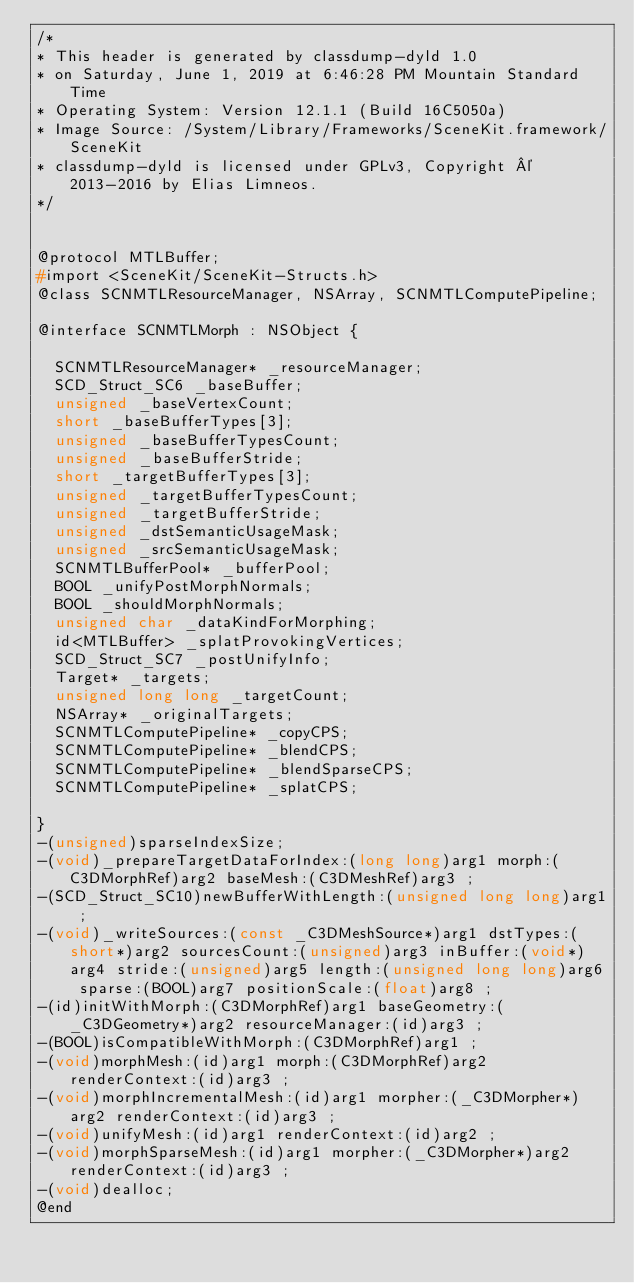Convert code to text. <code><loc_0><loc_0><loc_500><loc_500><_C_>/*
* This header is generated by classdump-dyld 1.0
* on Saturday, June 1, 2019 at 6:46:28 PM Mountain Standard Time
* Operating System: Version 12.1.1 (Build 16C5050a)
* Image Source: /System/Library/Frameworks/SceneKit.framework/SceneKit
* classdump-dyld is licensed under GPLv3, Copyright © 2013-2016 by Elias Limneos.
*/


@protocol MTLBuffer;
#import <SceneKit/SceneKit-Structs.h>
@class SCNMTLResourceManager, NSArray, SCNMTLComputePipeline;

@interface SCNMTLMorph : NSObject {

	SCNMTLResourceManager* _resourceManager;
	SCD_Struct_SC6 _baseBuffer;
	unsigned _baseVertexCount;
	short _baseBufferTypes[3];
	unsigned _baseBufferTypesCount;
	unsigned _baseBufferStride;
	short _targetBufferTypes[3];
	unsigned _targetBufferTypesCount;
	unsigned _targetBufferStride;
	unsigned _dstSemanticUsageMask;
	unsigned _srcSemanticUsageMask;
	SCNMTLBufferPool* _bufferPool;
	BOOL _unifyPostMorphNormals;
	BOOL _shouldMorphNormals;
	unsigned char _dataKindForMorphing;
	id<MTLBuffer> _splatProvokingVertices;
	SCD_Struct_SC7 _postUnifyInfo;
	Target* _targets;
	unsigned long long _targetCount;
	NSArray* _originalTargets;
	SCNMTLComputePipeline* _copyCPS;
	SCNMTLComputePipeline* _blendCPS;
	SCNMTLComputePipeline* _blendSparseCPS;
	SCNMTLComputePipeline* _splatCPS;

}
-(unsigned)sparseIndexSize;
-(void)_prepareTargetDataForIndex:(long long)arg1 morph:(C3DMorphRef)arg2 baseMesh:(C3DMeshRef)arg3 ;
-(SCD_Struct_SC10)newBufferWithLength:(unsigned long long)arg1 ;
-(void)_writeSources:(const _C3DMeshSource*)arg1 dstTypes:(short*)arg2 sourcesCount:(unsigned)arg3 inBuffer:(void*)arg4 stride:(unsigned)arg5 length:(unsigned long long)arg6 sparse:(BOOL)arg7 positionScale:(float)arg8 ;
-(id)initWithMorph:(C3DMorphRef)arg1 baseGeometry:(_C3DGeometry*)arg2 resourceManager:(id)arg3 ;
-(BOOL)isCompatibleWithMorph:(C3DMorphRef)arg1 ;
-(void)morphMesh:(id)arg1 morph:(C3DMorphRef)arg2 renderContext:(id)arg3 ;
-(void)morphIncrementalMesh:(id)arg1 morpher:(_C3DMorpher*)arg2 renderContext:(id)arg3 ;
-(void)unifyMesh:(id)arg1 renderContext:(id)arg2 ;
-(void)morphSparseMesh:(id)arg1 morpher:(_C3DMorpher*)arg2 renderContext:(id)arg3 ;
-(void)dealloc;
@end

</code> 